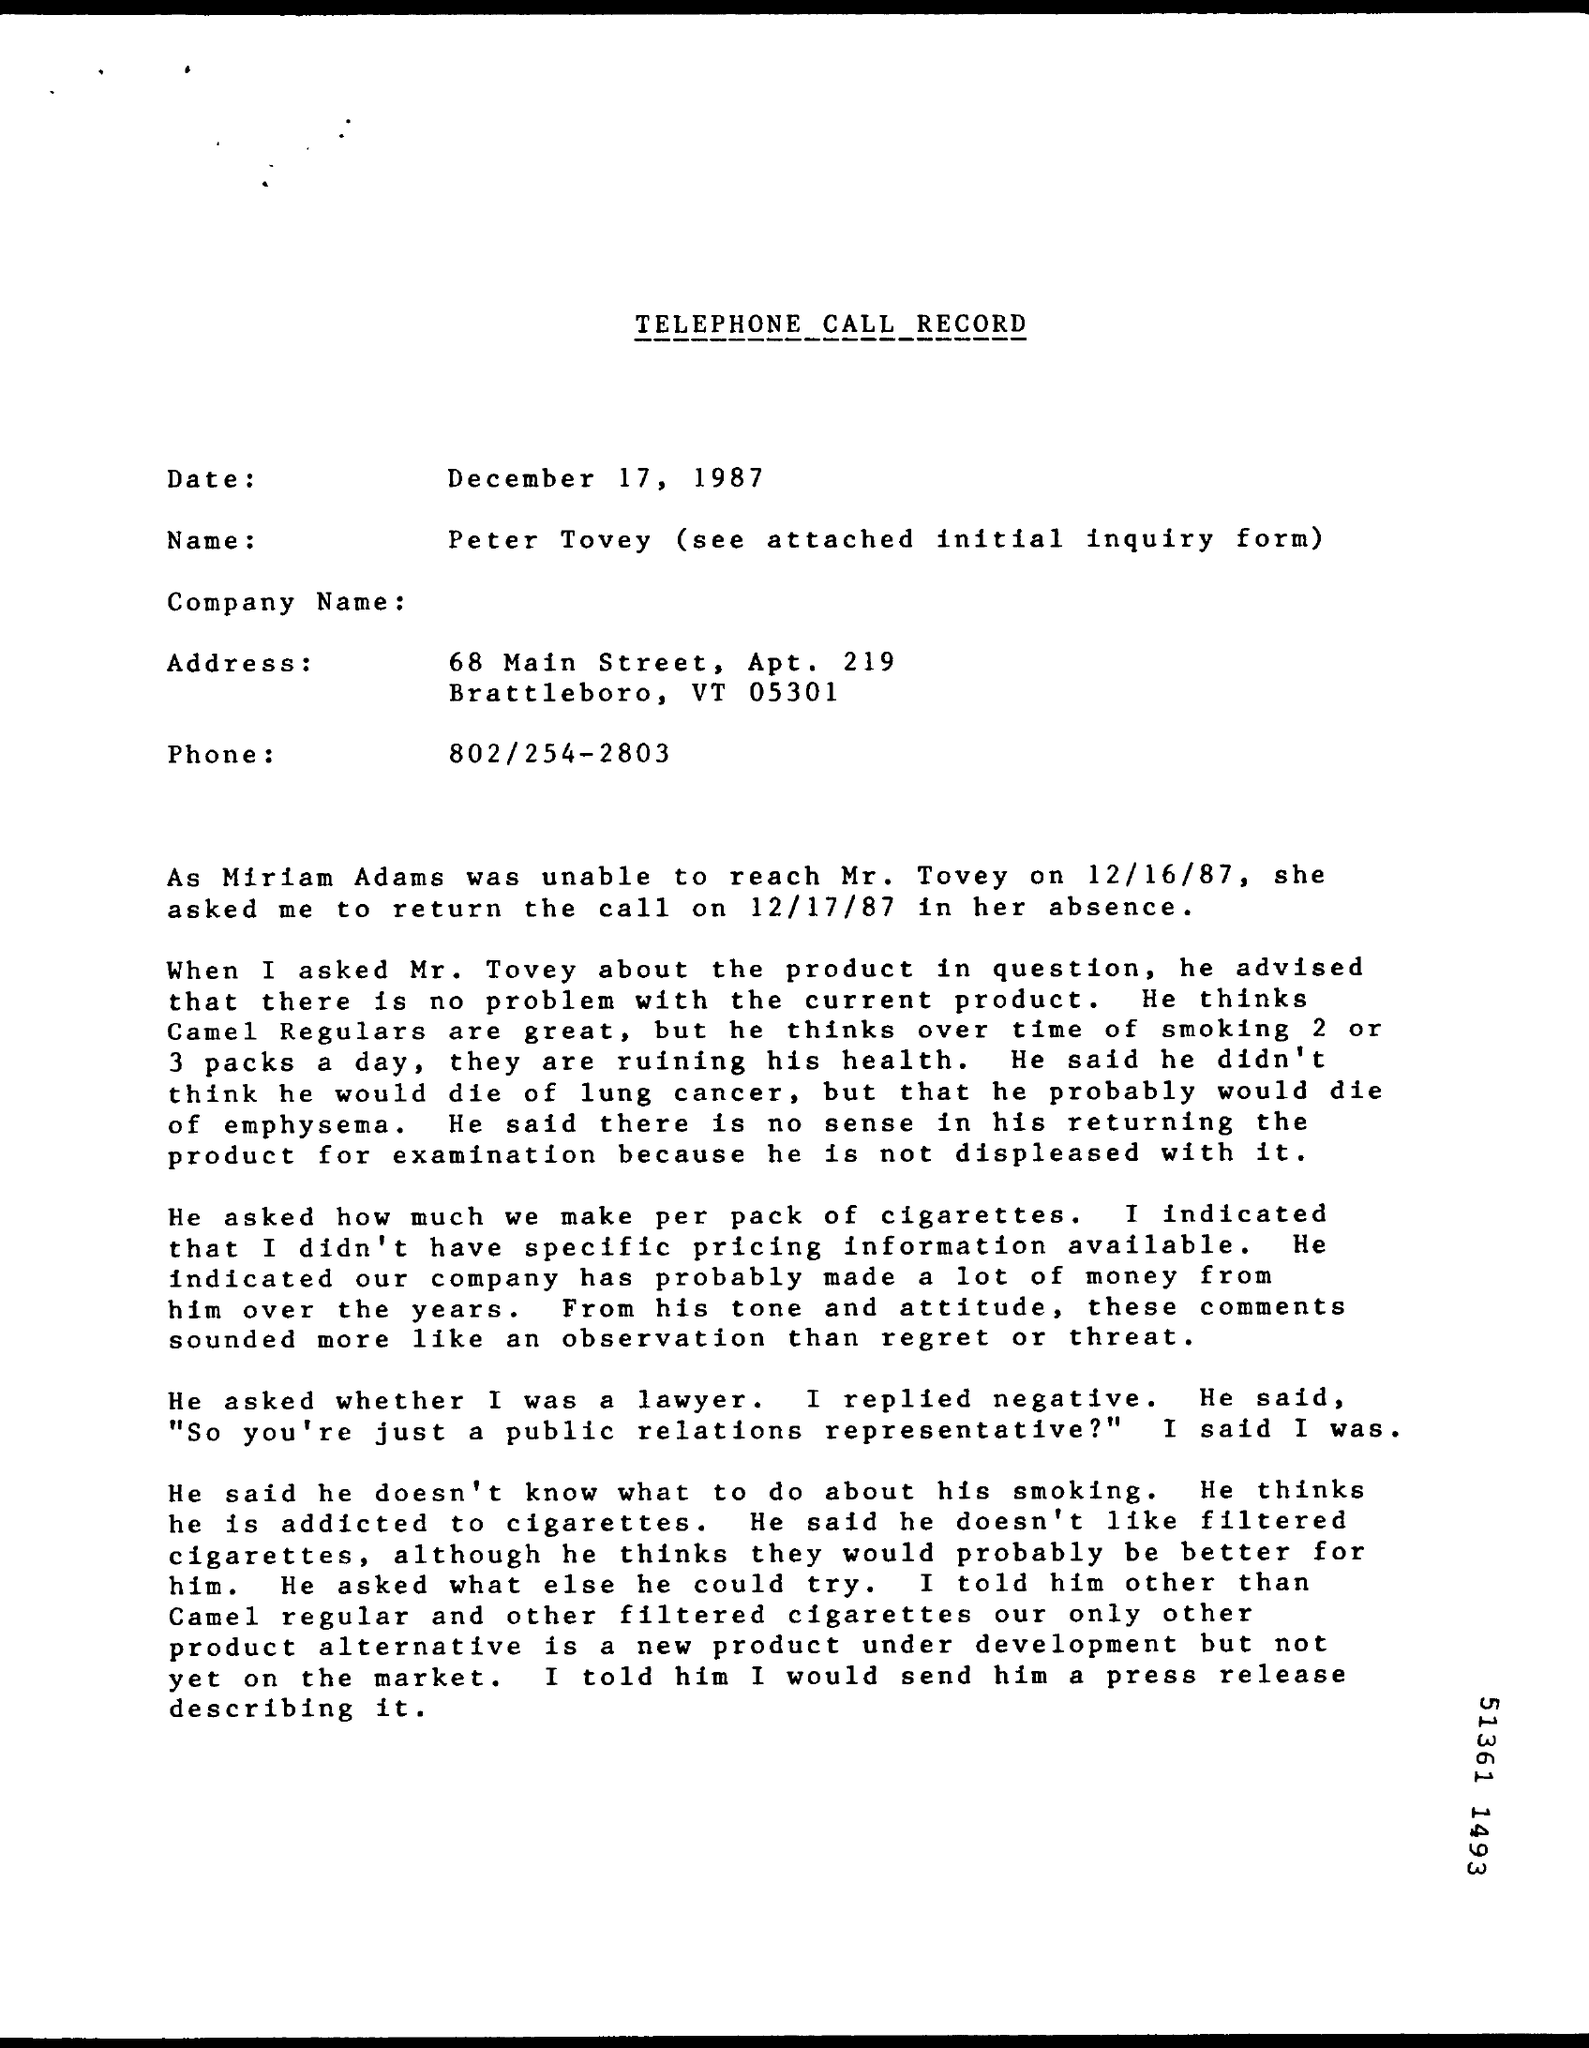What is the Title of the document?
Offer a terse response. Telephone call record. What is the Date?
Make the answer very short. December 17, 1987. What is the Name?
Offer a very short reply. Peter Tovey. 